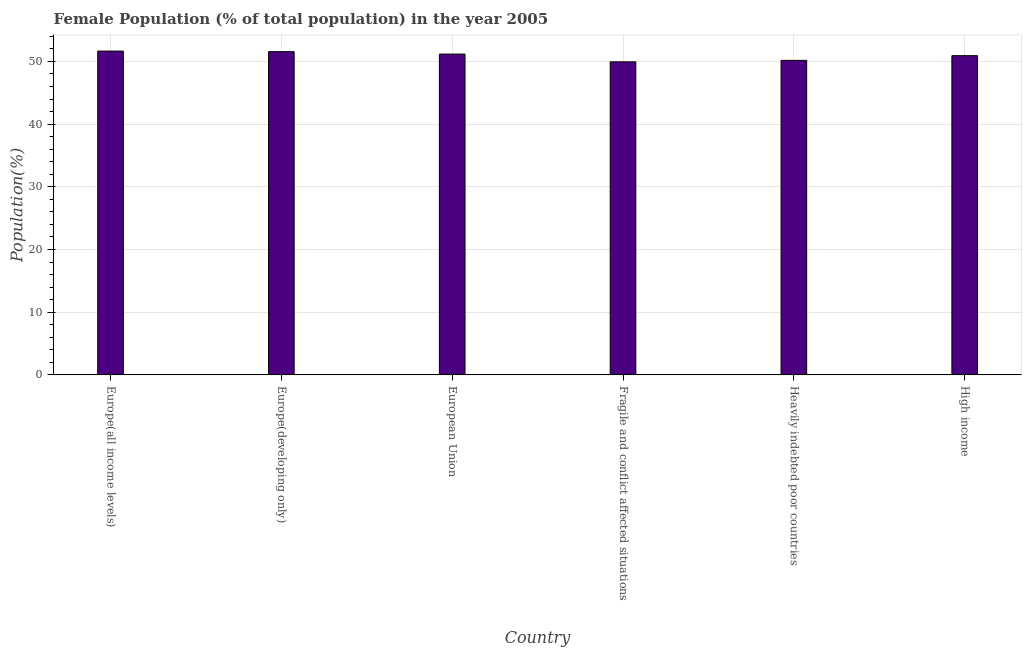Does the graph contain grids?
Your answer should be very brief. Yes. What is the title of the graph?
Offer a very short reply. Female Population (% of total population) in the year 2005. What is the label or title of the X-axis?
Provide a succinct answer. Country. What is the label or title of the Y-axis?
Offer a terse response. Population(%). What is the female population in High income?
Ensure brevity in your answer.  50.91. Across all countries, what is the maximum female population?
Offer a very short reply. 51.65. Across all countries, what is the minimum female population?
Offer a terse response. 49.93. In which country was the female population maximum?
Give a very brief answer. Europe(all income levels). In which country was the female population minimum?
Your answer should be very brief. Fragile and conflict affected situations. What is the sum of the female population?
Offer a terse response. 305.39. What is the difference between the female population in Europe(all income levels) and High income?
Give a very brief answer. 0.73. What is the average female population per country?
Give a very brief answer. 50.9. What is the median female population?
Offer a terse response. 51.04. In how many countries, is the female population greater than 10 %?
Provide a succinct answer. 6. Is the difference between the female population in Europe(all income levels) and Europe(developing only) greater than the difference between any two countries?
Offer a terse response. No. What is the difference between the highest and the second highest female population?
Your answer should be very brief. 0.09. Is the sum of the female population in Europe(all income levels) and Heavily indebted poor countries greater than the maximum female population across all countries?
Your answer should be compact. Yes. What is the difference between the highest and the lowest female population?
Your answer should be very brief. 1.71. In how many countries, is the female population greater than the average female population taken over all countries?
Offer a terse response. 4. How many countries are there in the graph?
Your response must be concise. 6. What is the difference between two consecutive major ticks on the Y-axis?
Provide a short and direct response. 10. Are the values on the major ticks of Y-axis written in scientific E-notation?
Ensure brevity in your answer.  No. What is the Population(%) in Europe(all income levels)?
Give a very brief answer. 51.65. What is the Population(%) of Europe(developing only)?
Ensure brevity in your answer.  51.56. What is the Population(%) in European Union?
Offer a terse response. 51.17. What is the Population(%) of Fragile and conflict affected situations?
Make the answer very short. 49.93. What is the Population(%) in Heavily indebted poor countries?
Keep it short and to the point. 50.16. What is the Population(%) of High income?
Keep it short and to the point. 50.91. What is the difference between the Population(%) in Europe(all income levels) and Europe(developing only)?
Give a very brief answer. 0.09. What is the difference between the Population(%) in Europe(all income levels) and European Union?
Your answer should be compact. 0.48. What is the difference between the Population(%) in Europe(all income levels) and Fragile and conflict affected situations?
Ensure brevity in your answer.  1.71. What is the difference between the Population(%) in Europe(all income levels) and Heavily indebted poor countries?
Make the answer very short. 1.49. What is the difference between the Population(%) in Europe(all income levels) and High income?
Your answer should be compact. 0.73. What is the difference between the Population(%) in Europe(developing only) and European Union?
Ensure brevity in your answer.  0.39. What is the difference between the Population(%) in Europe(developing only) and Fragile and conflict affected situations?
Give a very brief answer. 1.62. What is the difference between the Population(%) in Europe(developing only) and Heavily indebted poor countries?
Offer a terse response. 1.39. What is the difference between the Population(%) in Europe(developing only) and High income?
Make the answer very short. 0.64. What is the difference between the Population(%) in European Union and Fragile and conflict affected situations?
Your response must be concise. 1.23. What is the difference between the Population(%) in European Union and Heavily indebted poor countries?
Provide a short and direct response. 1. What is the difference between the Population(%) in European Union and High income?
Provide a succinct answer. 0.25. What is the difference between the Population(%) in Fragile and conflict affected situations and Heavily indebted poor countries?
Provide a short and direct response. -0.23. What is the difference between the Population(%) in Fragile and conflict affected situations and High income?
Provide a short and direct response. -0.98. What is the difference between the Population(%) in Heavily indebted poor countries and High income?
Give a very brief answer. -0.75. What is the ratio of the Population(%) in Europe(all income levels) to that in Europe(developing only)?
Your answer should be very brief. 1. What is the ratio of the Population(%) in Europe(all income levels) to that in European Union?
Ensure brevity in your answer.  1.01. What is the ratio of the Population(%) in Europe(all income levels) to that in Fragile and conflict affected situations?
Your response must be concise. 1.03. What is the ratio of the Population(%) in Europe(all income levels) to that in Heavily indebted poor countries?
Your response must be concise. 1.03. What is the ratio of the Population(%) in Europe(developing only) to that in Fragile and conflict affected situations?
Offer a very short reply. 1.03. What is the ratio of the Population(%) in Europe(developing only) to that in Heavily indebted poor countries?
Your response must be concise. 1.03. What is the ratio of the Population(%) in European Union to that in Heavily indebted poor countries?
Your answer should be compact. 1.02. What is the ratio of the Population(%) in European Union to that in High income?
Your answer should be very brief. 1. What is the ratio of the Population(%) in Heavily indebted poor countries to that in High income?
Make the answer very short. 0.98. 